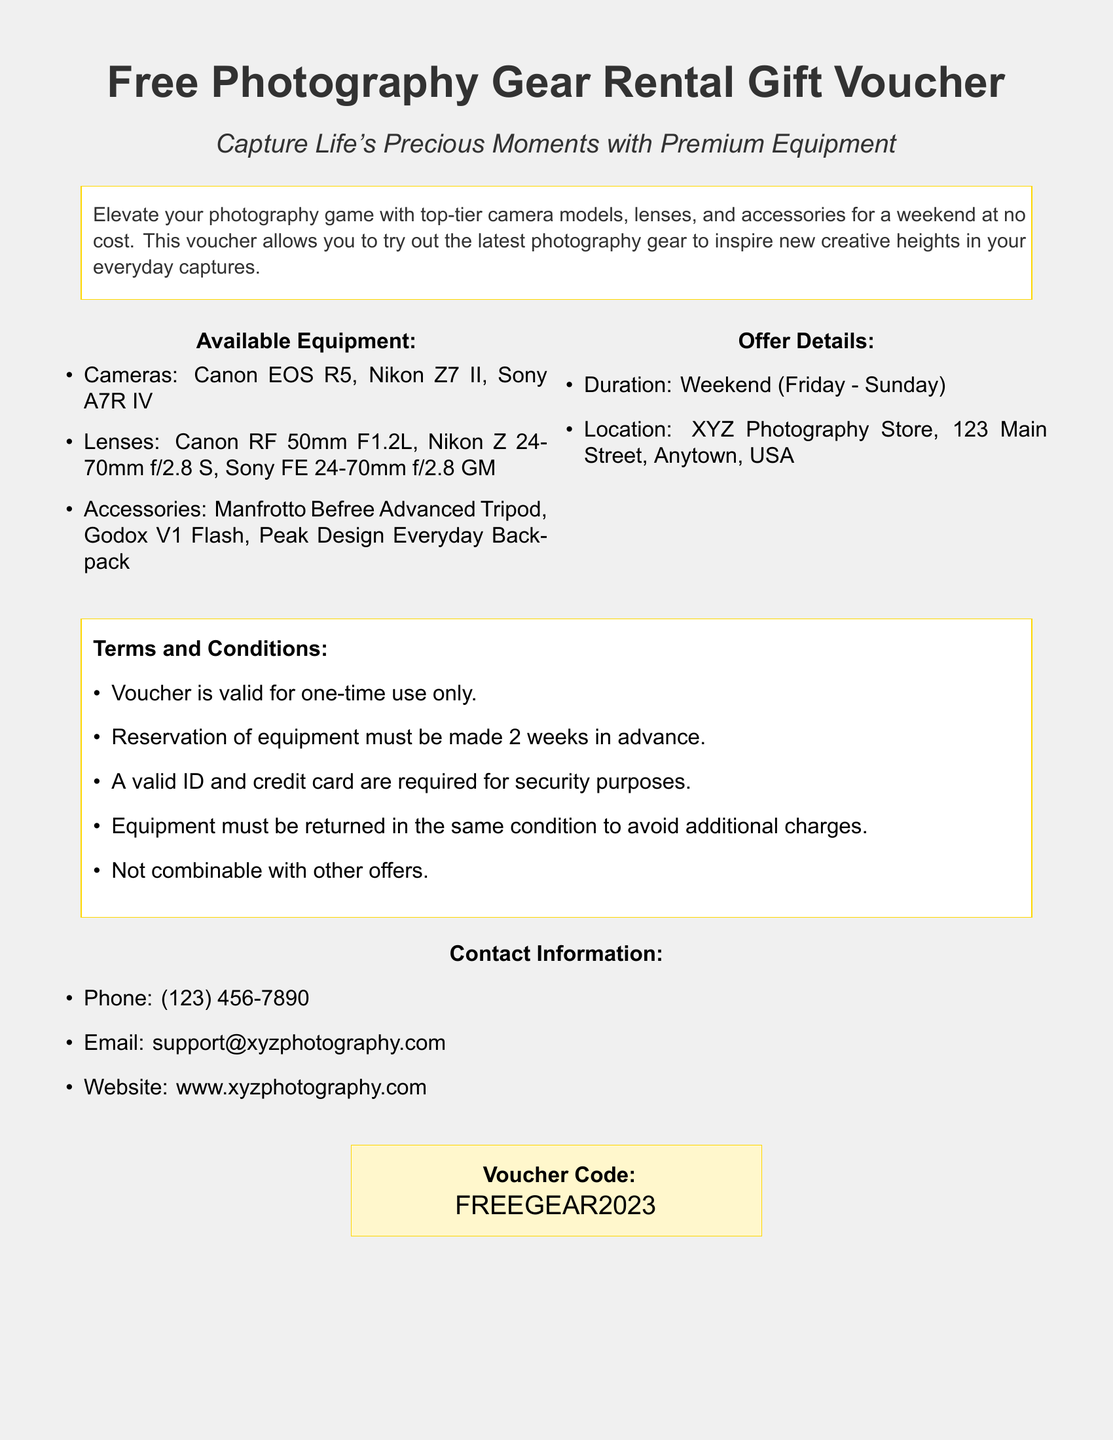What is the title of the voucher? The title is prominently displayed at the top of the document and indicates the purpose of the voucher.
Answer: Free Photography Gear Rental Gift Voucher What are the types of available cameras? This information is found in the list detailing the types of equipment available for rent.
Answer: Canon EOS R5, Nikon Z7 II, Sony A7R IV What is the rental period for the gear? The document specifies the duration of the rental period.
Answer: Weekend (Friday - Sunday) Where is the pick-up location for the equipment? The location is stated in the offer details section of the document.
Answer: XYZ Photography Store, 123 Main Street, Anytown, USA What is required for equipment reservation? The terms clearly outline what is needed to make a reservation for the equipment.
Answer: 2 weeks in advance Is the voucher combinable with other offers? This detail is mentioned in the terms and conditions section.
Answer: No What is the contact email for inquiries? The contact information section provides an email for support.
Answer: support@xyzphotography.com What is the voucher code? The code is presented in a highlighted box towards the end of the document.
Answer: FREEGEAR2023 How many different types of lenses are listed? The lenses are detailed in a bullet point format which indicates the variety available.
Answer: 3 